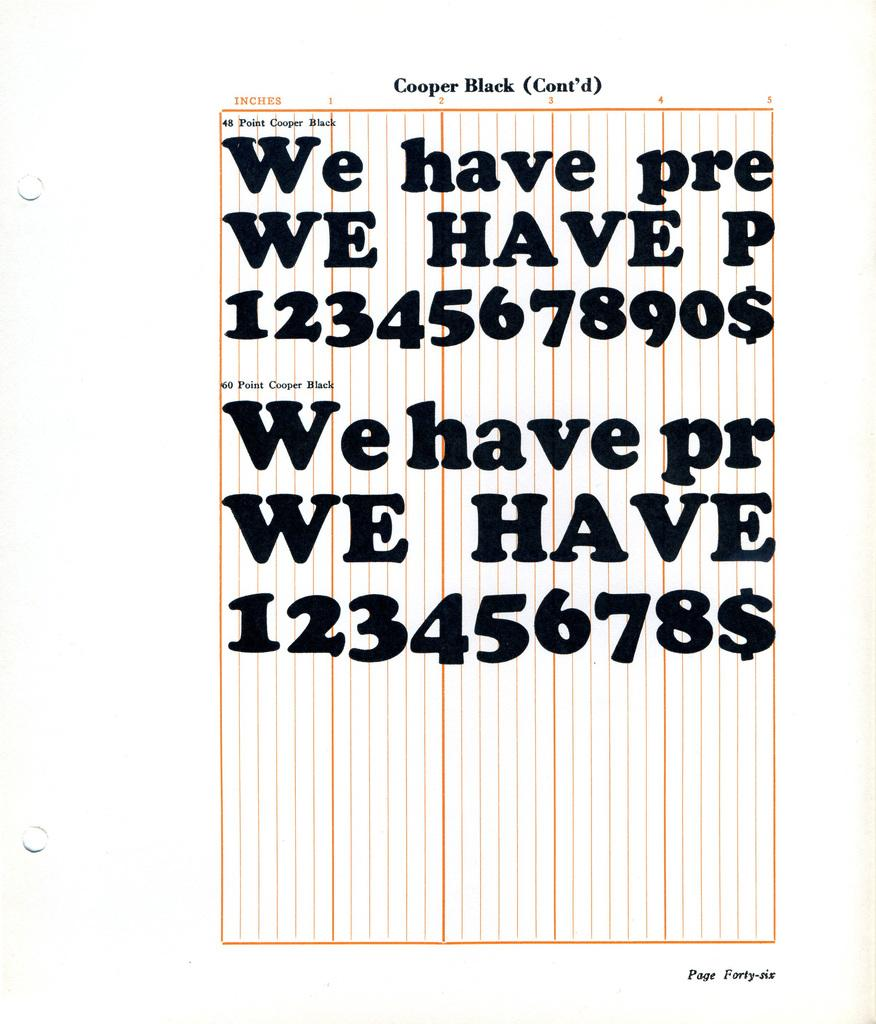<image>
Create a compact narrative representing the image presented. Page that says Cooper Black on the top and page forty-six on the bottom. 